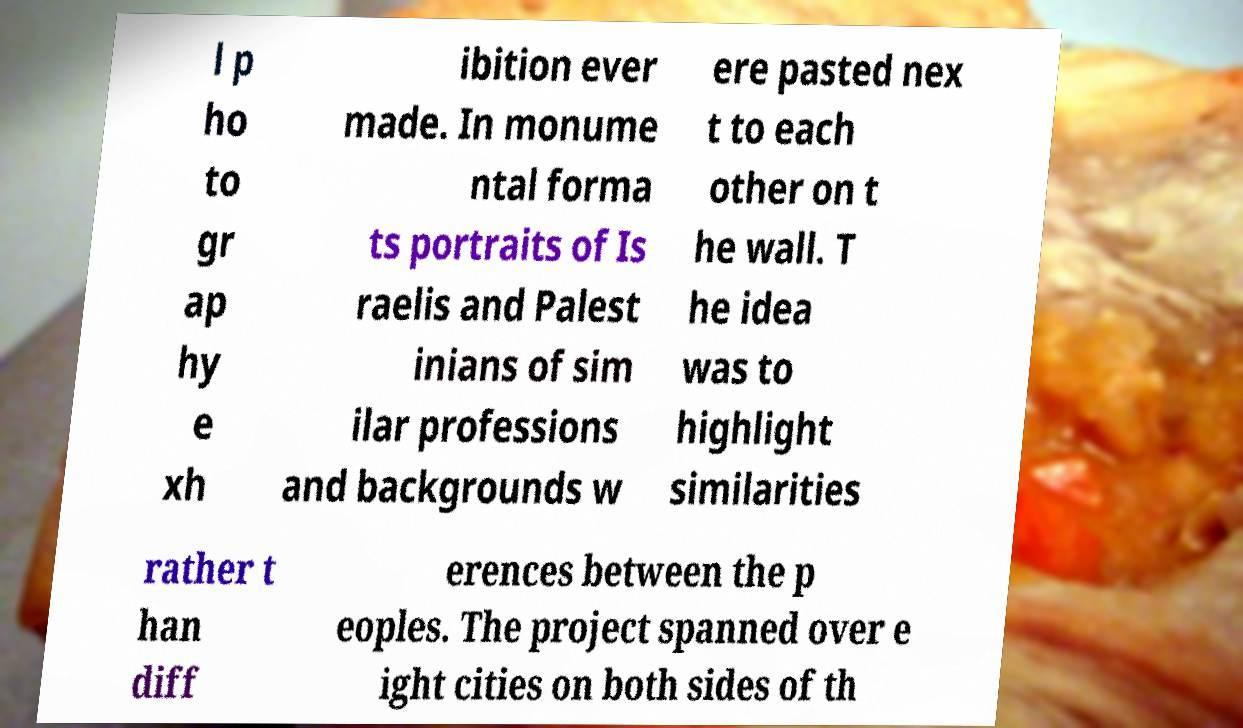Please identify and transcribe the text found in this image. l p ho to gr ap hy e xh ibition ever made. In monume ntal forma ts portraits of Is raelis and Palest inians of sim ilar professions and backgrounds w ere pasted nex t to each other on t he wall. T he idea was to highlight similarities rather t han diff erences between the p eoples. The project spanned over e ight cities on both sides of th 